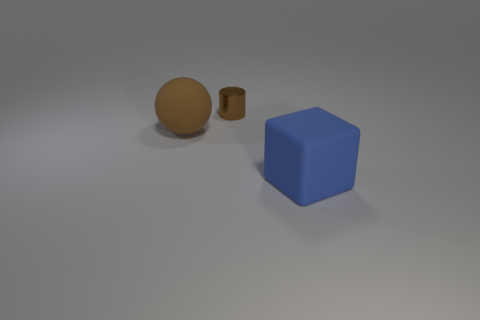What time of day does the lighting in the scene suggest? The lighting in the scene is soft and diffused with no hard shadows, suggesting an indoor setting rather than a specific time of day. It appears to be artificial lighting, likely from an overhead source. 